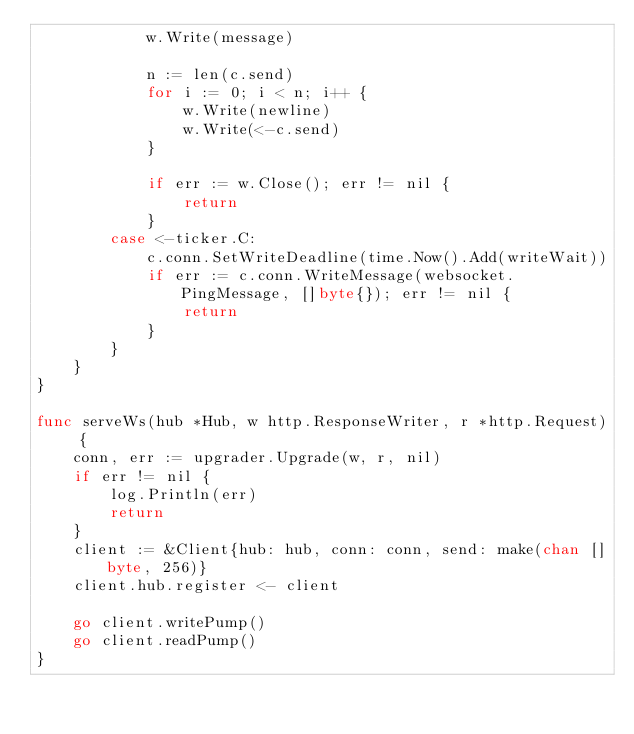<code> <loc_0><loc_0><loc_500><loc_500><_Go_>			w.Write(message)

			n := len(c.send)
			for i := 0; i < n; i++ {
				w.Write(newline)
				w.Write(<-c.send)
			}

			if err := w.Close(); err != nil {
				return
			}
		case <-ticker.C:
			c.conn.SetWriteDeadline(time.Now().Add(writeWait))
			if err := c.conn.WriteMessage(websocket.PingMessage, []byte{}); err != nil {
				return
			}
		}
	}
}

func serveWs(hub *Hub, w http.ResponseWriter, r *http.Request) {
	conn, err := upgrader.Upgrade(w, r, nil)
	if err != nil {
		log.Println(err)
		return
	}
	client := &Client{hub: hub, conn: conn, send: make(chan []byte, 256)}
	client.hub.register <- client

	go client.writePump()
	go client.readPump()
}
</code> 